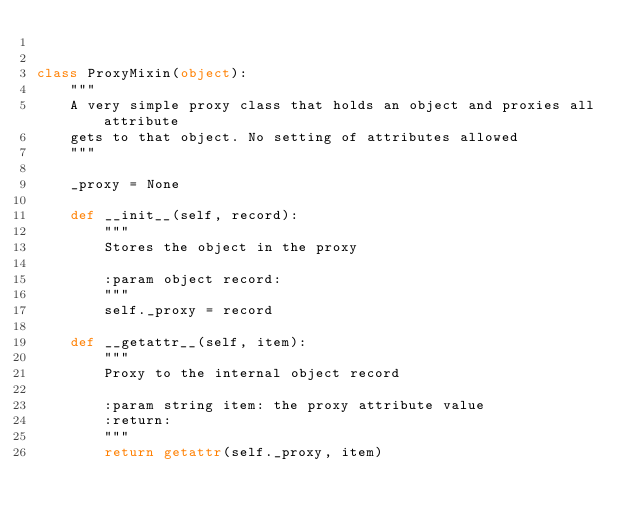<code> <loc_0><loc_0><loc_500><loc_500><_Python_>

class ProxyMixin(object):
    """
    A very simple proxy class that holds an object and proxies all attribute
    gets to that object. No setting of attributes allowed
    """

    _proxy = None

    def __init__(self, record):
        """
        Stores the object in the proxy

        :param object record:
        """
        self._proxy = record

    def __getattr__(self, item):
        """
        Proxy to the internal object record

        :param string item: the proxy attribute value
        :return:
        """
        return getattr(self._proxy, item)</code> 